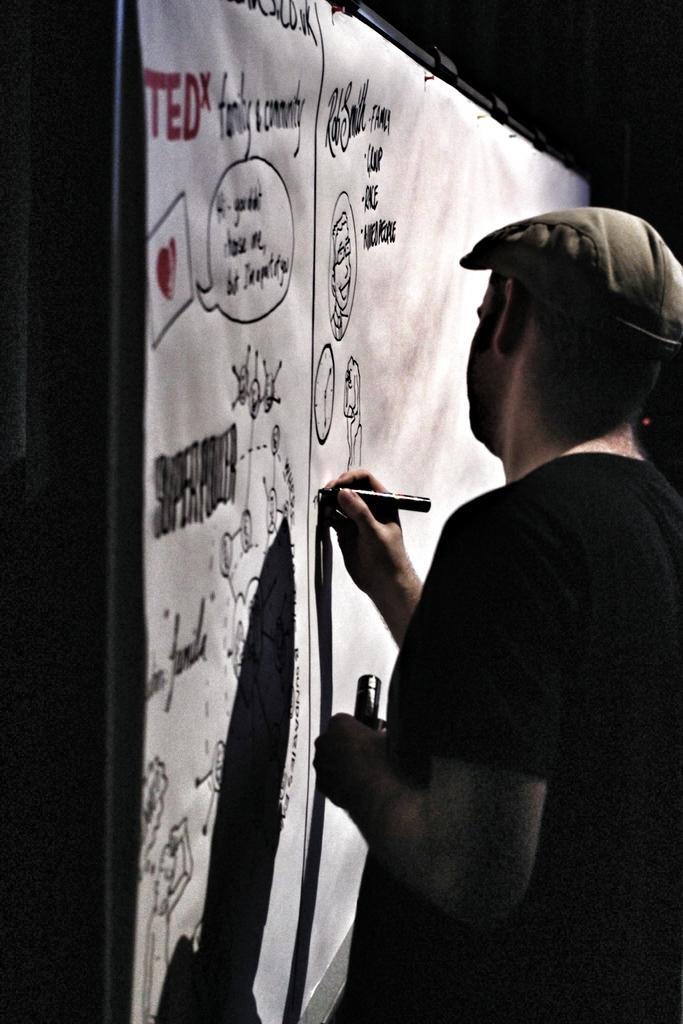Describe this image in one or two sentences. In this picture we can see a man holding a marker pen and an object in his hands. We can see the text and a few things on a paper visible on the board. There is the dark view visible in the background. 